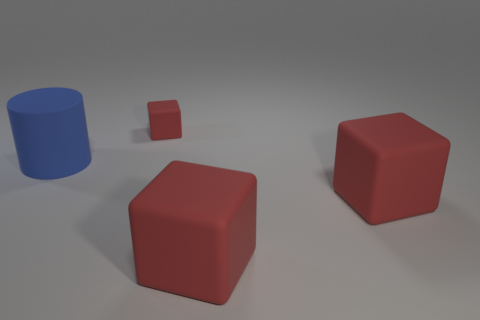Subtract all large red rubber blocks. How many blocks are left? 1 Add 3 small things. How many objects exist? 7 Subtract 1 cubes. How many cubes are left? 2 Subtract all cubes. How many objects are left? 1 Subtract all cyan cylinders. Subtract all green spheres. How many cylinders are left? 1 Subtract all red blocks. How many gray cylinders are left? 0 Subtract all big brown shiny objects. Subtract all blocks. How many objects are left? 1 Add 1 large red rubber blocks. How many large red rubber blocks are left? 3 Add 3 blue matte cylinders. How many blue matte cylinders exist? 4 Subtract 1 blue cylinders. How many objects are left? 3 